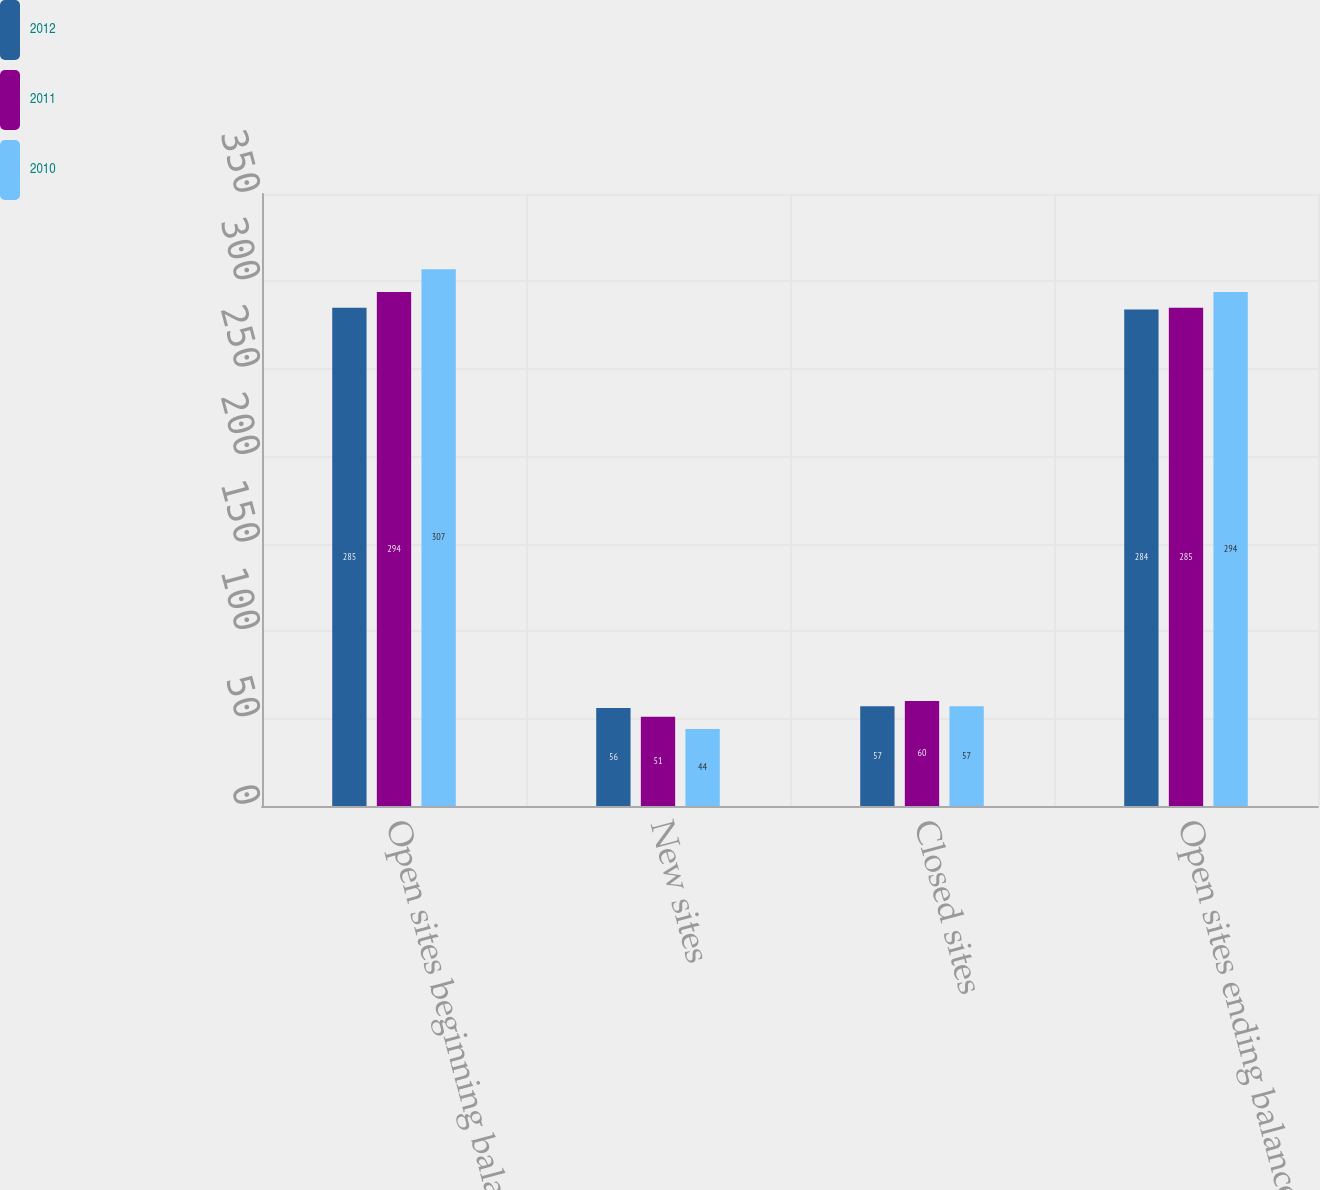Convert chart to OTSL. <chart><loc_0><loc_0><loc_500><loc_500><stacked_bar_chart><ecel><fcel>Open sites beginning balance<fcel>New sites<fcel>Closed sites<fcel>Open sites ending balance at<nl><fcel>2012<fcel>285<fcel>56<fcel>57<fcel>284<nl><fcel>2011<fcel>294<fcel>51<fcel>60<fcel>285<nl><fcel>2010<fcel>307<fcel>44<fcel>57<fcel>294<nl></chart> 